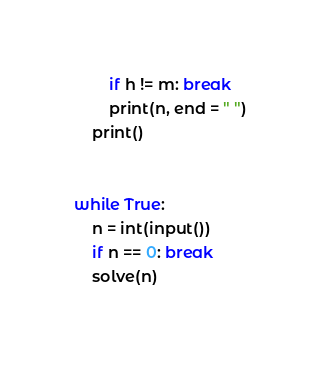Convert code to text. <code><loc_0><loc_0><loc_500><loc_500><_Python_>        if h != m: break
        print(n, end = " ")
    print()


while True:
    n = int(input())
    if n == 0: break
    solve(n)
    </code> 